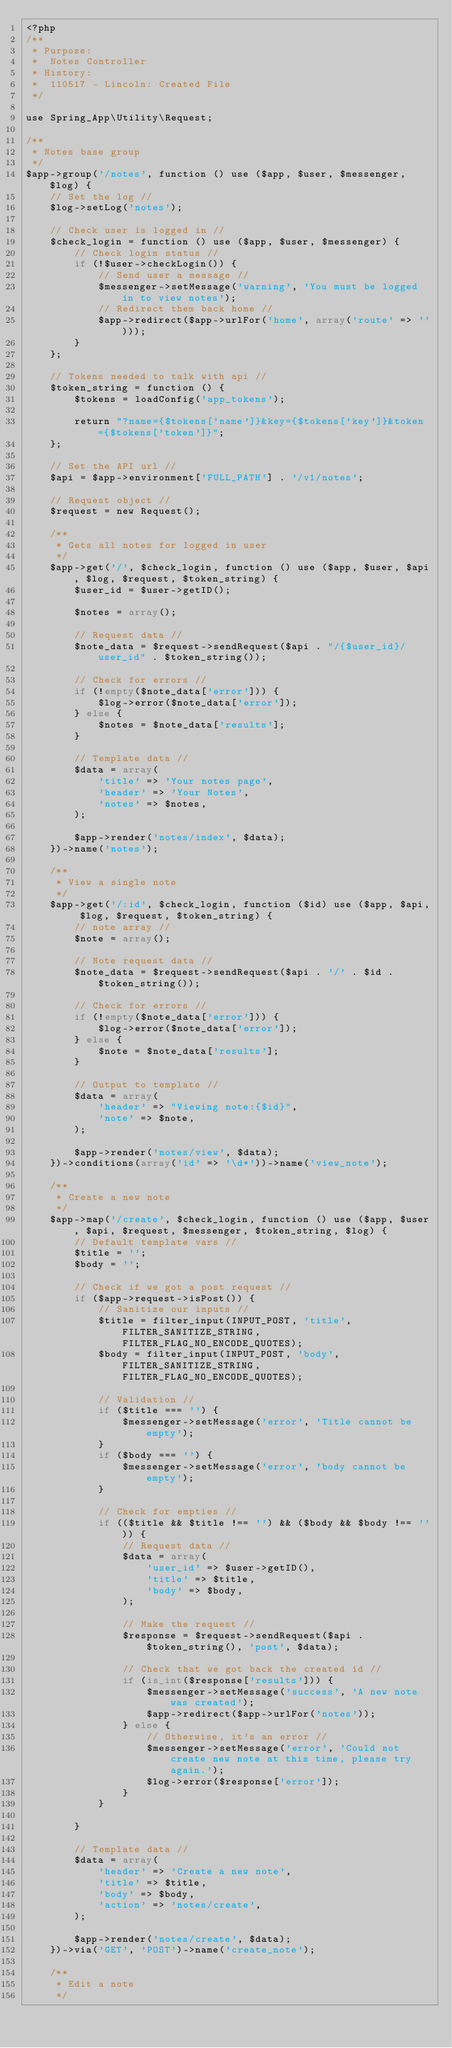<code> <loc_0><loc_0><loc_500><loc_500><_PHP_><?php
/**
 * Purpose:
 *  Notes Controller
 * History:
 *  110517 - Lincoln: Created File
 */

use Spring_App\Utility\Request;

/**
 * Notes base group
 */
$app->group('/notes', function () use ($app, $user, $messenger, $log) {
    // Set the log //
    $log->setLog('notes');

    // Check user is logged in //
    $check_login = function () use ($app, $user, $messenger) {
        // Check login status //
        if (!$user->checkLogin()) {
            // Send user a message //
            $messenger->setMessage('warning', 'You must be logged in to view notes');
            // Redirect them back home //
            $app->redirect($app->urlFor('home', array('route' => '')));
        }
    };

    // Tokens needed to talk with api //
    $token_string = function () {
        $tokens = loadConfig('app_tokens');

        return "?name={$tokens['name']}&key={$tokens['key']}&token={$tokens['token']}";
    };

    // Set the API url //
    $api = $app->environment['FULL_PATH'] . '/v1/notes';

    // Request object //
    $request = new Request();

    /**
     * Gets all notes for logged in user
     */
    $app->get('/', $check_login, function () use ($app, $user, $api, $log, $request, $token_string) {
        $user_id = $user->getID();

        $notes = array();

        // Request data //
        $note_data = $request->sendRequest($api . "/{$user_id}/user_id" . $token_string());

        // Check for errors //
        if (!empty($note_data['error'])) {
            $log->error($note_data['error']);
        } else {
            $notes = $note_data['results'];
        }

        // Template data //
        $data = array(
            'title' => 'Your notes page',
            'header' => 'Your Notes',
            'notes' => $notes,
        );

        $app->render('notes/index', $data);
    })->name('notes');

    /**
     * View a single note
     */
    $app->get('/:id', $check_login, function ($id) use ($app, $api, $log, $request, $token_string) {
        // note array //
        $note = array();

        // Note request data //
        $note_data = $request->sendRequest($api . '/' . $id . $token_string());

        // Check for errors //
        if (!empty($note_data['error'])) {
            $log->error($note_data['error']);
        } else {
            $note = $note_data['results'];
        }

        // Output to template //
        $data = array(
            'header' => "Viewing note:{$id}",
            'note' => $note,
        );

        $app->render('notes/view', $data);
    })->conditions(array('id' => '\d*'))->name('view_note');

    /**
     * Create a new note
     */
    $app->map('/create', $check_login, function () use ($app, $user, $api, $request, $messenger, $token_string, $log) {
        // Default template vars //
        $title = '';
        $body = '';

        // Check if we got a post request //
        if ($app->request->isPost()) {
            // Sanitize our inputs //
            $title = filter_input(INPUT_POST, 'title', FILTER_SANITIZE_STRING, FILTER_FLAG_NO_ENCODE_QUOTES);
            $body = filter_input(INPUT_POST, 'body', FILTER_SANITIZE_STRING, FILTER_FLAG_NO_ENCODE_QUOTES);

            // Validation //
            if ($title === '') {
                $messenger->setMessage('error', 'Title cannot be empty');
            }
            if ($body === '') {
                $messenger->setMessage('error', 'body cannot be empty');
            }

            // Check for empties //
            if (($title && $title !== '') && ($body && $body !== '')) {
                // Request data //
                $data = array(
                    'user_id' => $user->getID(),
                    'title' => $title,
                    'body' => $body,
                );

                // Make the request //
                $response = $request->sendRequest($api . $token_string(), 'post', $data);

                // Check that we got back the created id //
                if (is_int($response['results'])) {
                    $messenger->setMessage('success', 'A new note was created');
                    $app->redirect($app->urlFor('notes'));
                } else {
                    // Otherwise, it's an error //
                    $messenger->setMessage('error', 'Could not create new note at this time, please try again.');
                    $log->error($response['error']);
                }
            }

        }

        // Template data //
        $data = array(
            'header' => 'Create a new note',
            'title' => $title,
            'body' => $body,
            'action' => 'notes/create',
        );

        $app->render('notes/create', $data);
    })->via('GET', 'POST')->name('create_note');

    /**
     * Edit a note
     */</code> 